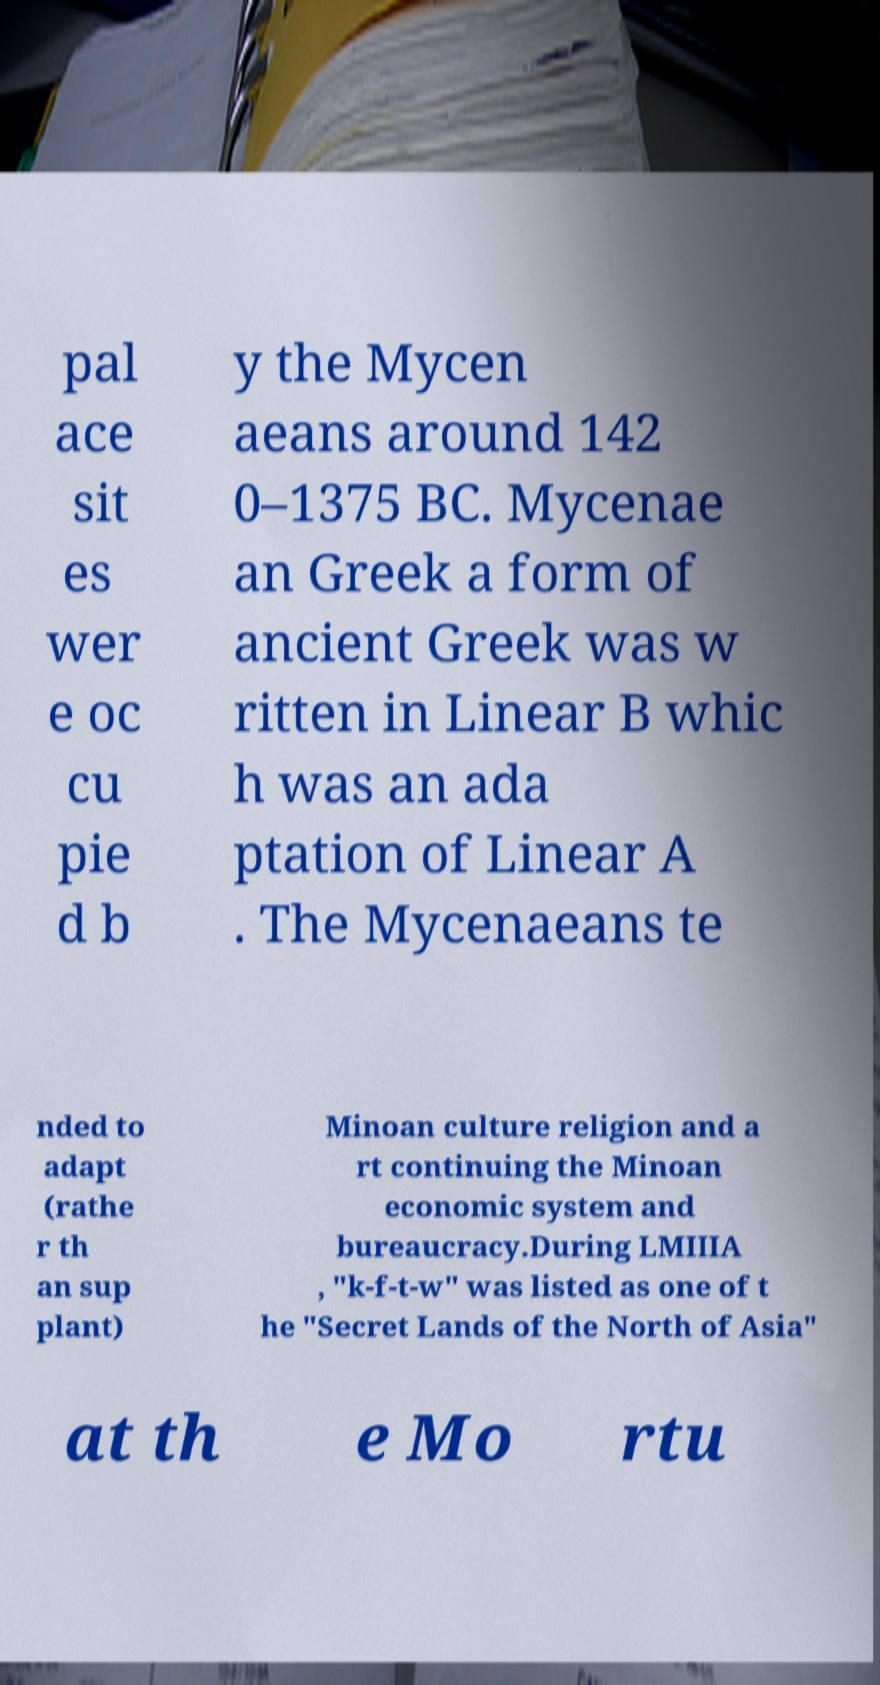For documentation purposes, I need the text within this image transcribed. Could you provide that? pal ace sit es wer e oc cu pie d b y the Mycen aeans around 142 0–1375 BC. Mycenae an Greek a form of ancient Greek was w ritten in Linear B whic h was an ada ptation of Linear A . The Mycenaeans te nded to adapt (rathe r th an sup plant) Minoan culture religion and a rt continuing the Minoan economic system and bureaucracy.During LMIIIA , "k-f-t-w" was listed as one of t he "Secret Lands of the North of Asia" at th e Mo rtu 